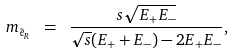<formula> <loc_0><loc_0><loc_500><loc_500>m _ { \tilde { e } _ { R } } \ = \ \frac { s \sqrt { E _ { + } E _ { - } } } { \sqrt { s } ( E _ { + } + E _ { - } ) - 2 E _ { + } E _ { - } } ,</formula> 